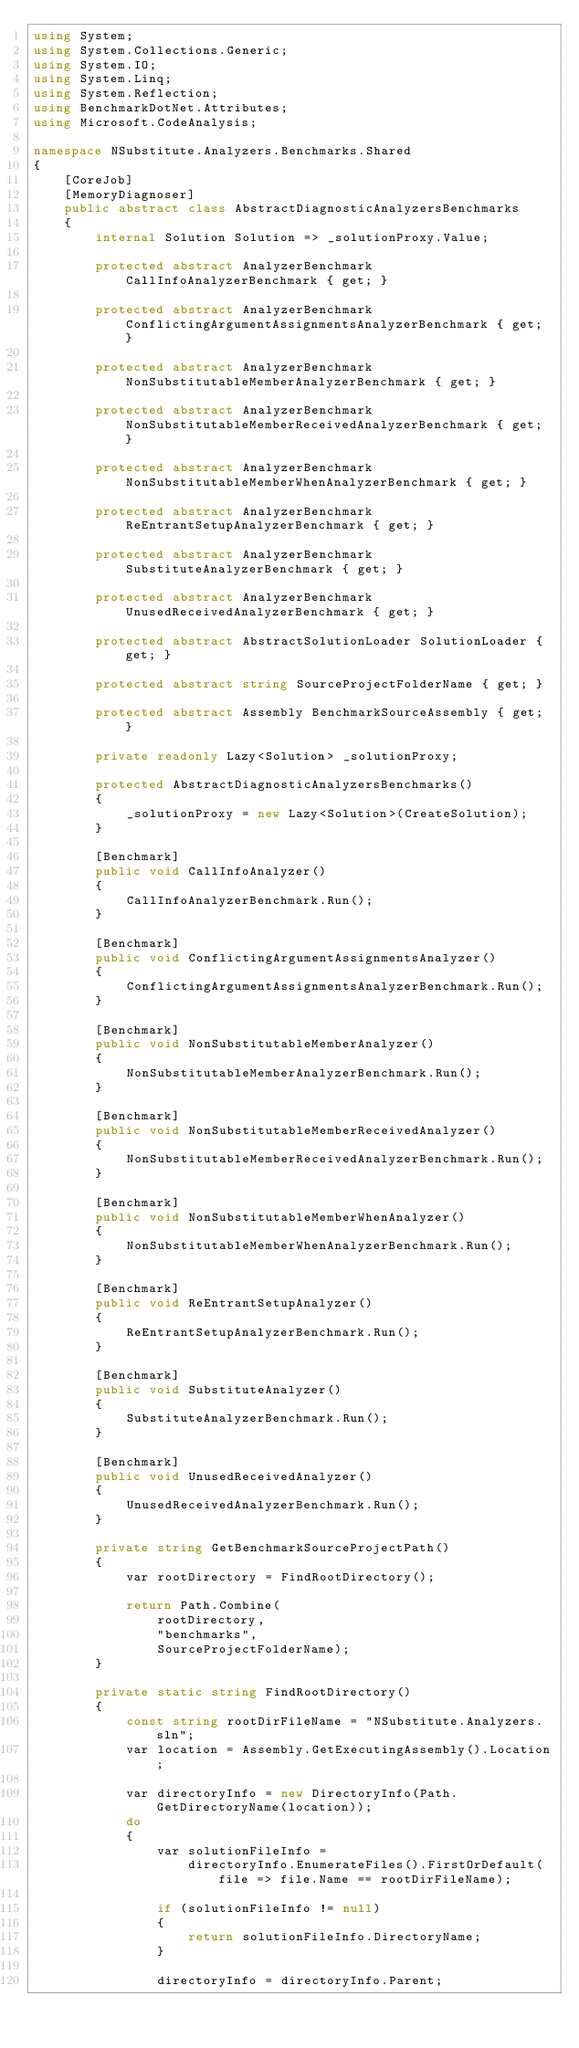<code> <loc_0><loc_0><loc_500><loc_500><_C#_>using System;
using System.Collections.Generic;
using System.IO;
using System.Linq;
using System.Reflection;
using BenchmarkDotNet.Attributes;
using Microsoft.CodeAnalysis;

namespace NSubstitute.Analyzers.Benchmarks.Shared
{
    [CoreJob]
    [MemoryDiagnoser]
    public abstract class AbstractDiagnosticAnalyzersBenchmarks
    {
        internal Solution Solution => _solutionProxy.Value;

        protected abstract AnalyzerBenchmark CallInfoAnalyzerBenchmark { get; }

        protected abstract AnalyzerBenchmark ConflictingArgumentAssignmentsAnalyzerBenchmark { get; }

        protected abstract AnalyzerBenchmark NonSubstitutableMemberAnalyzerBenchmark { get; }

        protected abstract AnalyzerBenchmark NonSubstitutableMemberReceivedAnalyzerBenchmark { get; }

        protected abstract AnalyzerBenchmark NonSubstitutableMemberWhenAnalyzerBenchmark { get; }

        protected abstract AnalyzerBenchmark ReEntrantSetupAnalyzerBenchmark { get; }

        protected abstract AnalyzerBenchmark SubstituteAnalyzerBenchmark { get; }

        protected abstract AnalyzerBenchmark UnusedReceivedAnalyzerBenchmark { get; }

        protected abstract AbstractSolutionLoader SolutionLoader { get; }

        protected abstract string SourceProjectFolderName { get; }

        protected abstract Assembly BenchmarkSourceAssembly { get; }

        private readonly Lazy<Solution> _solutionProxy;

        protected AbstractDiagnosticAnalyzersBenchmarks()
        {
            _solutionProxy = new Lazy<Solution>(CreateSolution);
        }

        [Benchmark]
        public void CallInfoAnalyzer()
        {
            CallInfoAnalyzerBenchmark.Run();
        }

        [Benchmark]
        public void ConflictingArgumentAssignmentsAnalyzer()
        {
            ConflictingArgumentAssignmentsAnalyzerBenchmark.Run();
        }

        [Benchmark]
        public void NonSubstitutableMemberAnalyzer()
        {
            NonSubstitutableMemberAnalyzerBenchmark.Run();
        }

        [Benchmark]
        public void NonSubstitutableMemberReceivedAnalyzer()
        {
            NonSubstitutableMemberReceivedAnalyzerBenchmark.Run();
        }

        [Benchmark]
        public void NonSubstitutableMemberWhenAnalyzer()
        {
            NonSubstitutableMemberWhenAnalyzerBenchmark.Run();
        }

        [Benchmark]
        public void ReEntrantSetupAnalyzer()
        {
            ReEntrantSetupAnalyzerBenchmark.Run();
        }

        [Benchmark]
        public void SubstituteAnalyzer()
        {
            SubstituteAnalyzerBenchmark.Run();
        }

        [Benchmark]
        public void UnusedReceivedAnalyzer()
        {
            UnusedReceivedAnalyzerBenchmark.Run();
        }

        private string GetBenchmarkSourceProjectPath()
        {
            var rootDirectory = FindRootDirectory();

            return Path.Combine(
                rootDirectory,
                "benchmarks",
                SourceProjectFolderName);
        }

        private static string FindRootDirectory()
        {
            const string rootDirFileName = "NSubstitute.Analyzers.sln";
            var location = Assembly.GetExecutingAssembly().Location;

            var directoryInfo = new DirectoryInfo(Path.GetDirectoryName(location));
            do
            {
                var solutionFileInfo =
                    directoryInfo.EnumerateFiles().FirstOrDefault(file => file.Name == rootDirFileName);

                if (solutionFileInfo != null)
                {
                    return solutionFileInfo.DirectoryName;
                }

                directoryInfo = directoryInfo.Parent;</code> 